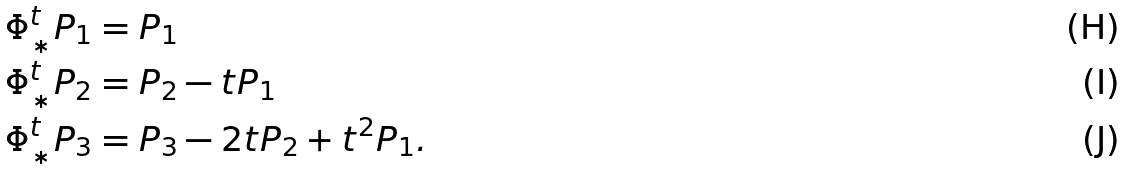Convert formula to latex. <formula><loc_0><loc_0><loc_500><loc_500>& \Phi ^ { t } _ { * } P _ { 1 } = P _ { 1 } \\ & \Phi ^ { t } _ { * } P _ { 2 } = P _ { 2 } - t P _ { 1 } \\ & \Phi ^ { t } _ { * } P _ { 3 } = P _ { 3 } - 2 t P _ { 2 } + t ^ { 2 } P _ { 1 } .</formula> 